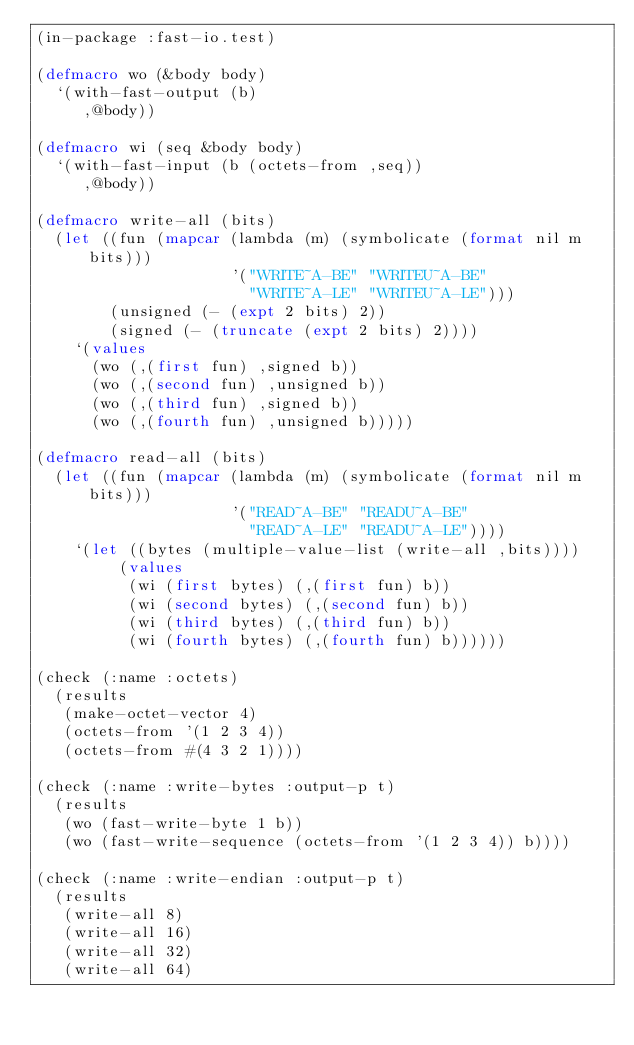Convert code to text. <code><loc_0><loc_0><loc_500><loc_500><_Lisp_>(in-package :fast-io.test)

(defmacro wo (&body body)
  `(with-fast-output (b)
     ,@body))

(defmacro wi (seq &body body)
  `(with-fast-input (b (octets-from ,seq))
     ,@body))

(defmacro write-all (bits)
  (let ((fun (mapcar (lambda (m) (symbolicate (format nil m bits)))
                     '("WRITE~A-BE" "WRITEU~A-BE"
                       "WRITE~A-LE" "WRITEU~A-LE")))
        (unsigned (- (expt 2 bits) 2))
        (signed (- (truncate (expt 2 bits) 2))))
    `(values
      (wo (,(first fun) ,signed b))
      (wo (,(second fun) ,unsigned b))
      (wo (,(third fun) ,signed b))
      (wo (,(fourth fun) ,unsigned b)))))

(defmacro read-all (bits)
  (let ((fun (mapcar (lambda (m) (symbolicate (format nil m bits)))
                     '("READ~A-BE" "READU~A-BE"
                       "READ~A-LE" "READU~A-LE"))))
    `(let ((bytes (multiple-value-list (write-all ,bits))))
         (values
          (wi (first bytes) (,(first fun) b))
          (wi (second bytes) (,(second fun) b))
          (wi (third bytes) (,(third fun) b))
          (wi (fourth bytes) (,(fourth fun) b))))))

(check (:name :octets)
  (results
   (make-octet-vector 4)
   (octets-from '(1 2 3 4))
   (octets-from #(4 3 2 1))))

(check (:name :write-bytes :output-p t)
  (results
   (wo (fast-write-byte 1 b))
   (wo (fast-write-sequence (octets-from '(1 2 3 4)) b))))

(check (:name :write-endian :output-p t)
  (results
   (write-all 8)
   (write-all 16)
   (write-all 32)
   (write-all 64)</code> 